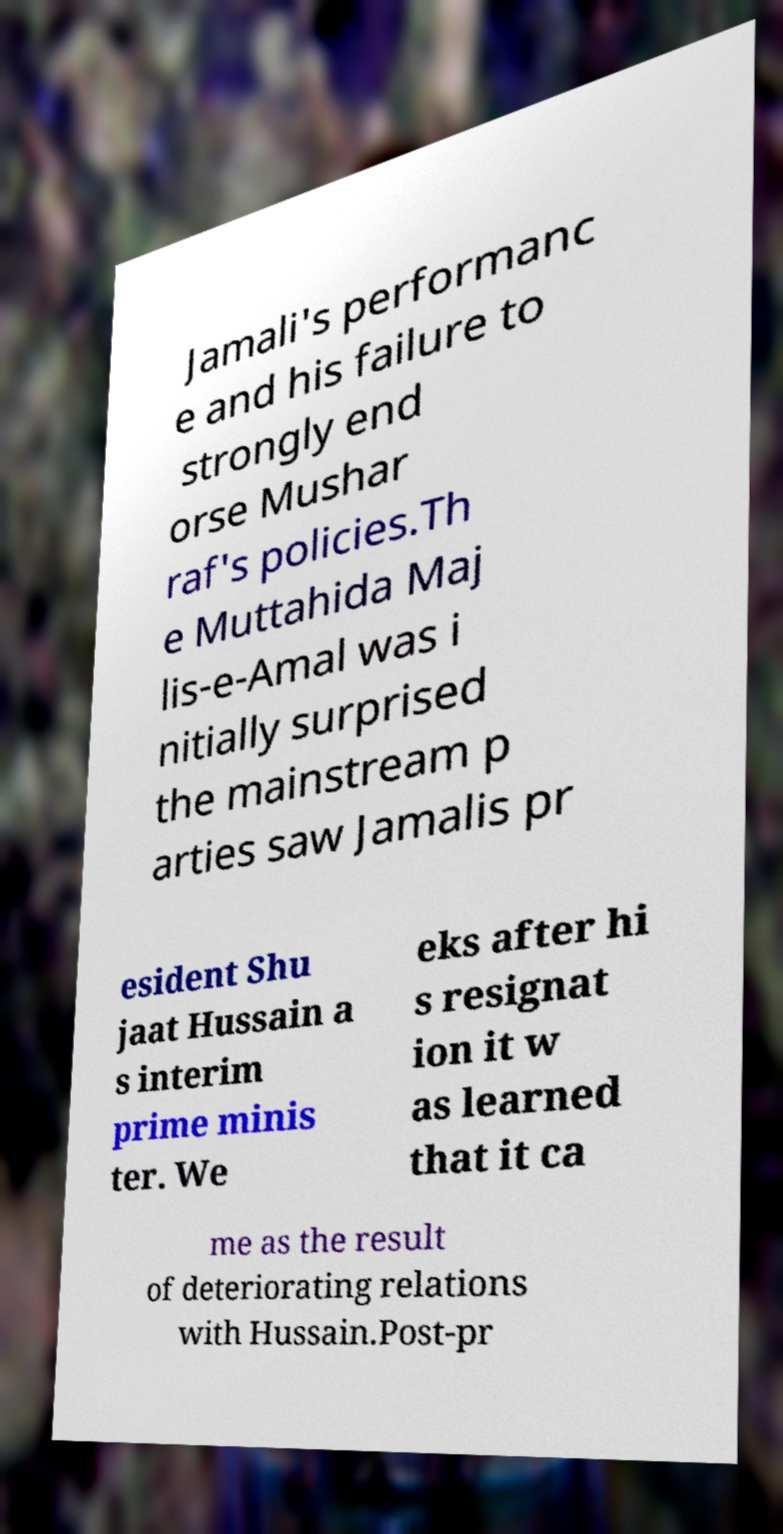Can you accurately transcribe the text from the provided image for me? Jamali's performanc e and his failure to strongly end orse Mushar raf's policies.Th e Muttahida Maj lis-e-Amal was i nitially surprised the mainstream p arties saw Jamalis pr esident Shu jaat Hussain a s interim prime minis ter. We eks after hi s resignat ion it w as learned that it ca me as the result of deteriorating relations with Hussain.Post-pr 